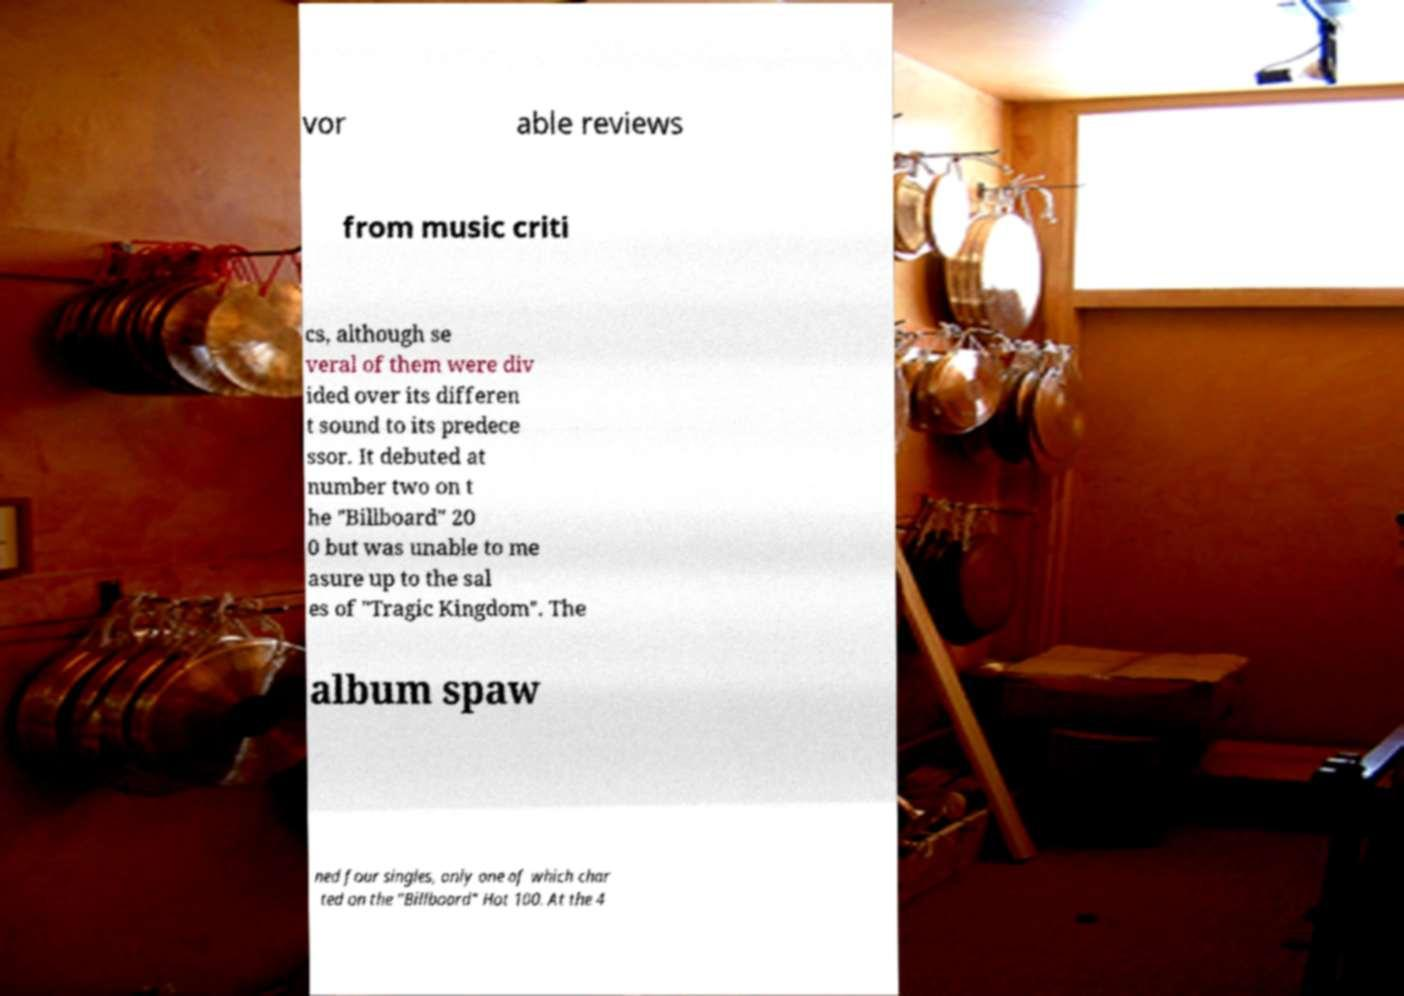There's text embedded in this image that I need extracted. Can you transcribe it verbatim? vor able reviews from music criti cs, although se veral of them were div ided over its differen t sound to its predece ssor. It debuted at number two on t he "Billboard" 20 0 but was unable to me asure up to the sal es of "Tragic Kingdom". The album spaw ned four singles, only one of which char ted on the "Billboard" Hot 100. At the 4 